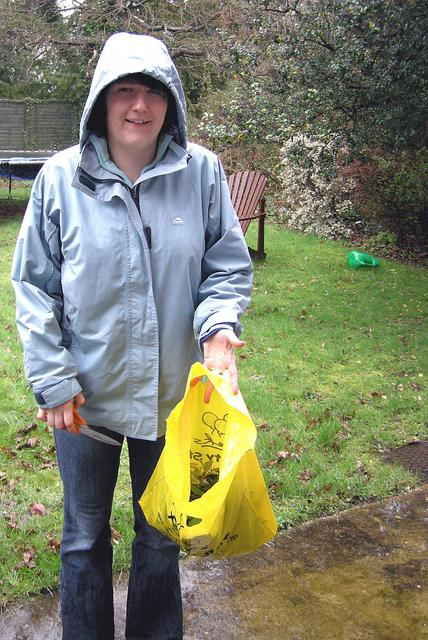What was probably stored in the container on the grass?

Choices:
A) detergent
B) marbles
C) rice
D) cake detergent 